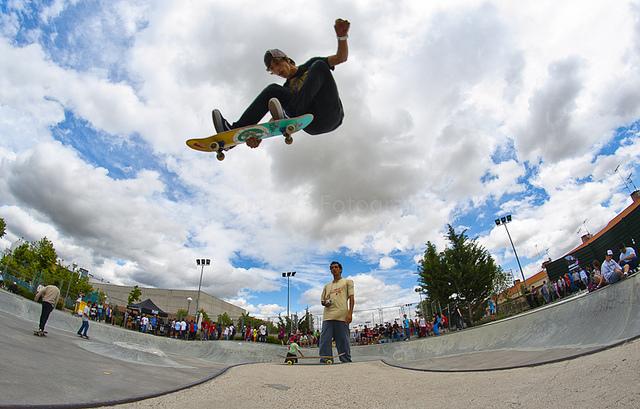What color is the skateboard wheels?
Write a very short answer. Yellow. Is the skater touching his skateboard?
Give a very brief answer. Yes. What is the weather like?
Concise answer only. Cloudy. What sport is shown?
Write a very short answer. Skateboarding. Is there anyone else in the picture?
Short answer required. Yes. What color is the top that the man is wearing?
Quick response, please. Black. Is this a snowboarder?
Concise answer only. No. What is the man doing?
Keep it brief. Skateboarding. Is he on a skateboard?
Quick response, please. Yes. What is white?
Be succinct. Clouds. Is this an event?
Give a very brief answer. Yes. Is he wearing a watch?
Keep it brief. Yes. Is anyone looking at the skater?
Answer briefly. Yes. What is the color of the man's shirt?
Answer briefly. Black. Do you see the shadow of the spectators?
Answer briefly. No. Is this a sunny day?
Write a very short answer. No. Is there a crowd watching?
Give a very brief answer. Yes. 